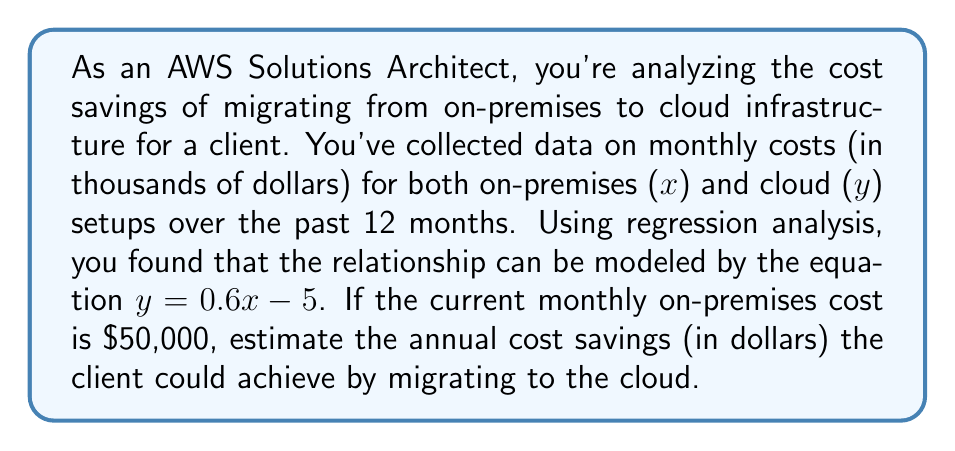What is the answer to this math problem? Let's approach this step-by-step:

1. We have the regression equation: $y = 0.6x - 5$
   Where $x$ is the on-premises cost and $y$ is the cloud cost (both in thousands of dollars).

2. The current monthly on-premises cost is $50,000, so $x = 50$ (in thousands).

3. Calculate the estimated monthly cloud cost:
   $y = 0.6(50) - 5$
   $y = 30 - 5 = 25$ (thousand dollars)
   So, the monthly cloud cost is $25,000.

4. Calculate the monthly savings:
   Monthly savings = On-premises cost - Cloud cost
   $50,000 - $25,000 = $25,000

5. To get annual savings, multiply by 12 months:
   Annual savings = $25,000 * 12 = $300,000

Therefore, the estimated annual cost savings is $300,000.
Answer: $300,000 